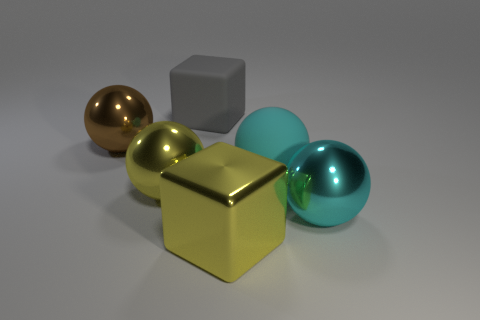Subtract all blue balls. Subtract all purple cubes. How many balls are left? 4 Add 1 big brown shiny balls. How many objects exist? 7 Subtract all spheres. How many objects are left? 2 Subtract 0 purple cubes. How many objects are left? 6 Subtract all purple matte blocks. Subtract all cyan matte balls. How many objects are left? 5 Add 2 large spheres. How many large spheres are left? 6 Add 2 large cyan matte objects. How many large cyan matte objects exist? 3 